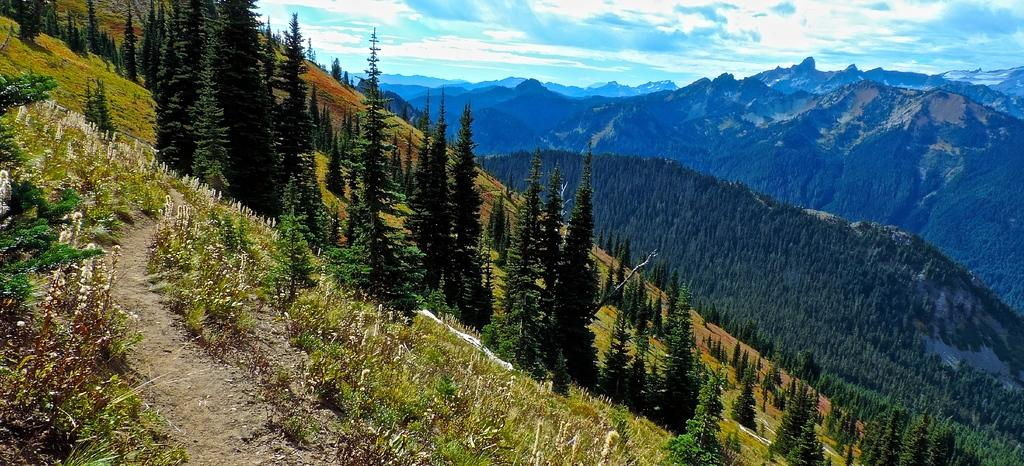What type of landscape is depicted in the image? The image shows trees and plants on sloppy land. Are there any mountains visible in the image? Yes, there are trees on mountains in the background of the image. What is the condition of the sky in the image? The sky is covered with clouds. How many clover leaves can be seen growing on the sloppy land in the image? There is no mention of clover in the image, so it is impossible to determine the number of clover leaves present. 